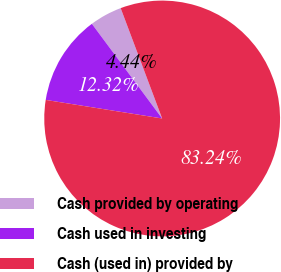Convert chart. <chart><loc_0><loc_0><loc_500><loc_500><pie_chart><fcel>Cash provided by operating<fcel>Cash used in investing<fcel>Cash (used in) provided by<nl><fcel>4.44%<fcel>12.32%<fcel>83.24%<nl></chart> 